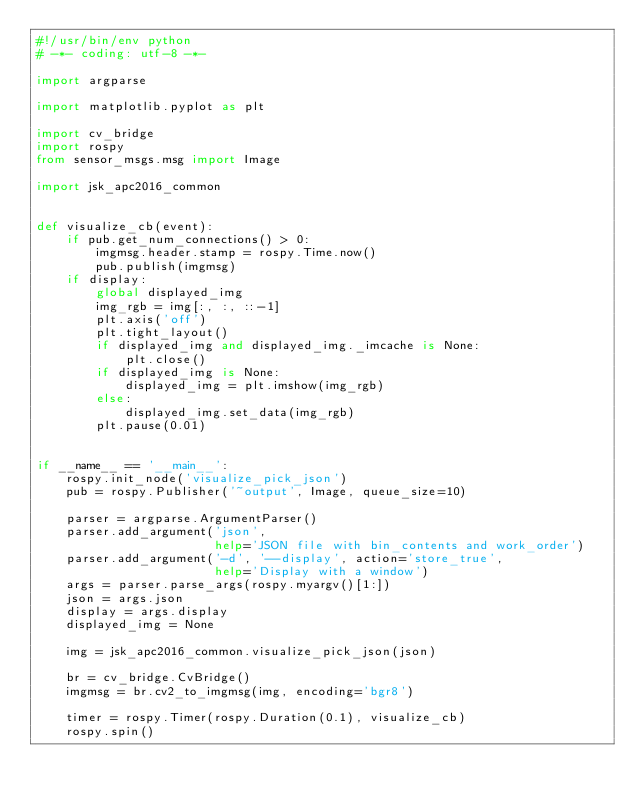<code> <loc_0><loc_0><loc_500><loc_500><_Python_>#!/usr/bin/env python
# -*- coding: utf-8 -*-

import argparse

import matplotlib.pyplot as plt

import cv_bridge
import rospy
from sensor_msgs.msg import Image

import jsk_apc2016_common


def visualize_cb(event):
    if pub.get_num_connections() > 0:
        imgmsg.header.stamp = rospy.Time.now()
        pub.publish(imgmsg)
    if display:
        global displayed_img
        img_rgb = img[:, :, ::-1]
        plt.axis('off')
        plt.tight_layout()
        if displayed_img and displayed_img._imcache is None:
            plt.close()
        if displayed_img is None:
            displayed_img = plt.imshow(img_rgb)
        else:
            displayed_img.set_data(img_rgb)
        plt.pause(0.01)


if __name__ == '__main__':
    rospy.init_node('visualize_pick_json')
    pub = rospy.Publisher('~output', Image, queue_size=10)

    parser = argparse.ArgumentParser()
    parser.add_argument('json',
                        help='JSON file with bin_contents and work_order')
    parser.add_argument('-d', '--display', action='store_true',
                        help='Display with a window')
    args = parser.parse_args(rospy.myargv()[1:])
    json = args.json
    display = args.display
    displayed_img = None

    img = jsk_apc2016_common.visualize_pick_json(json)

    br = cv_bridge.CvBridge()
    imgmsg = br.cv2_to_imgmsg(img, encoding='bgr8')

    timer = rospy.Timer(rospy.Duration(0.1), visualize_cb)
    rospy.spin()
</code> 